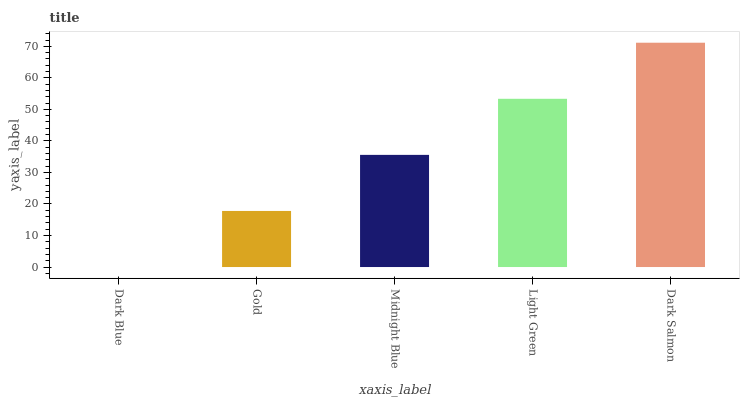Is Dark Blue the minimum?
Answer yes or no. Yes. Is Dark Salmon the maximum?
Answer yes or no. Yes. Is Gold the minimum?
Answer yes or no. No. Is Gold the maximum?
Answer yes or no. No. Is Gold greater than Dark Blue?
Answer yes or no. Yes. Is Dark Blue less than Gold?
Answer yes or no. Yes. Is Dark Blue greater than Gold?
Answer yes or no. No. Is Gold less than Dark Blue?
Answer yes or no. No. Is Midnight Blue the high median?
Answer yes or no. Yes. Is Midnight Blue the low median?
Answer yes or no. Yes. Is Dark Blue the high median?
Answer yes or no. No. Is Light Green the low median?
Answer yes or no. No. 